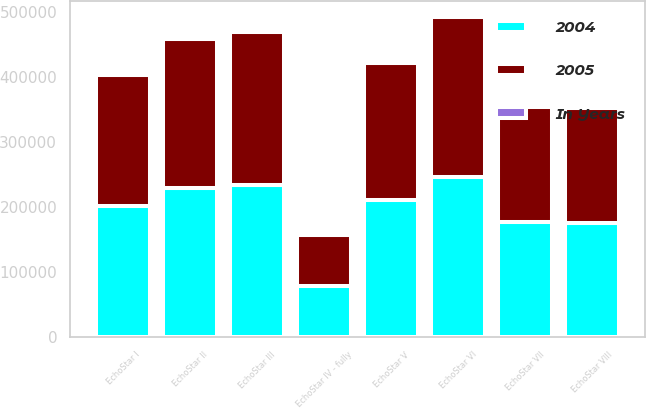Convert chart to OTSL. <chart><loc_0><loc_0><loc_500><loc_500><stacked_bar_chart><ecel><fcel>EchoStar I<fcel>EchoStar II<fcel>EchoStar III<fcel>EchoStar IV - fully<fcel>EchoStar V<fcel>EchoStar VI<fcel>EchoStar VII<fcel>EchoStar VIII<nl><fcel>In Years<fcel>12<fcel>12<fcel>12<fcel>4<fcel>9<fcel>12<fcel>12<fcel>12<nl><fcel>2004<fcel>201607<fcel>228694<fcel>234083<fcel>78511<fcel>210446<fcel>246022<fcel>177000<fcel>175801<nl><fcel>2005<fcel>201607<fcel>228694<fcel>234083<fcel>78511<fcel>210446<fcel>246022<fcel>177000<fcel>175801<nl></chart> 